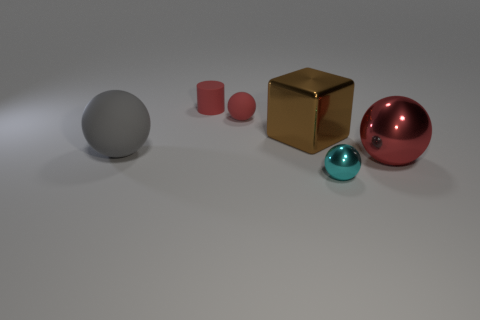Subtract all tiny red matte balls. How many balls are left? 3 Subtract all purple spheres. Subtract all blue cubes. How many spheres are left? 4 Add 1 large brown cubes. How many objects exist? 7 Subtract all spheres. How many objects are left? 2 Add 3 gray rubber cubes. How many gray rubber cubes exist? 3 Subtract 0 purple cylinders. How many objects are left? 6 Subtract all big red spheres. Subtract all big matte things. How many objects are left? 4 Add 4 big red balls. How many big red balls are left? 5 